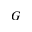<formula> <loc_0><loc_0><loc_500><loc_500>G</formula> 